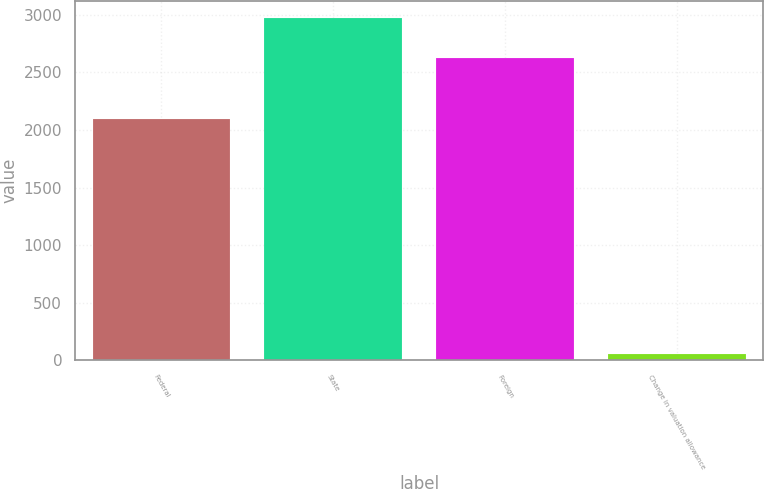Convert chart to OTSL. <chart><loc_0><loc_0><loc_500><loc_500><bar_chart><fcel>Federal<fcel>State<fcel>Foreign<fcel>Change in valuation allowance<nl><fcel>2099<fcel>2974<fcel>2626<fcel>52<nl></chart> 